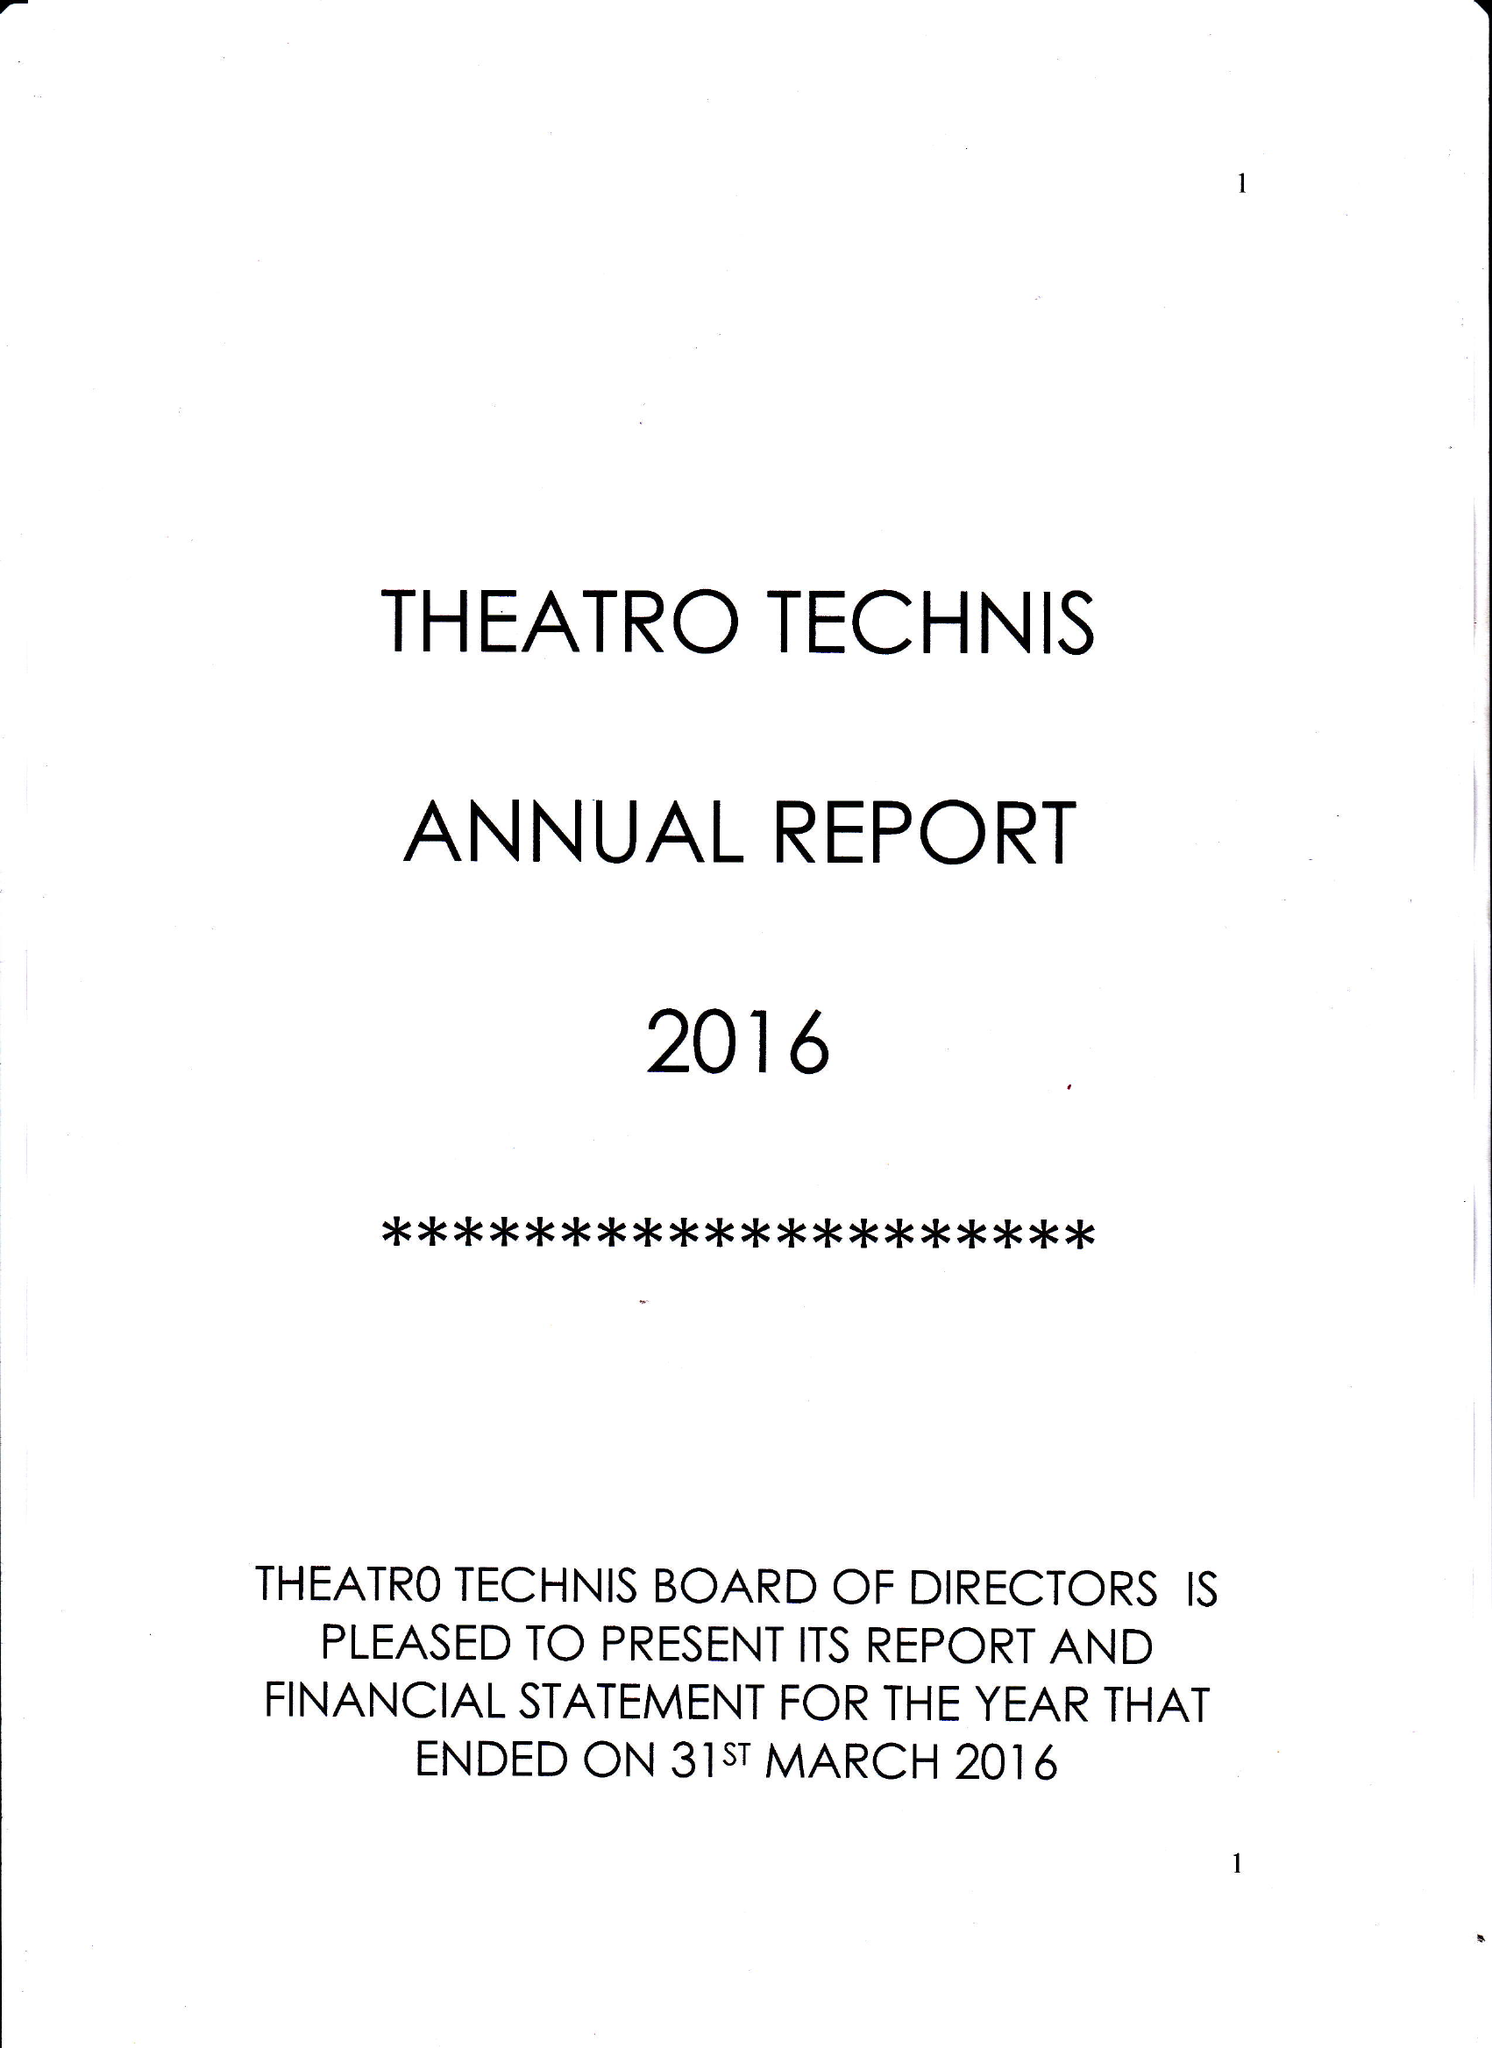What is the value for the charity_number?
Answer the question using a single word or phrase. 280885 